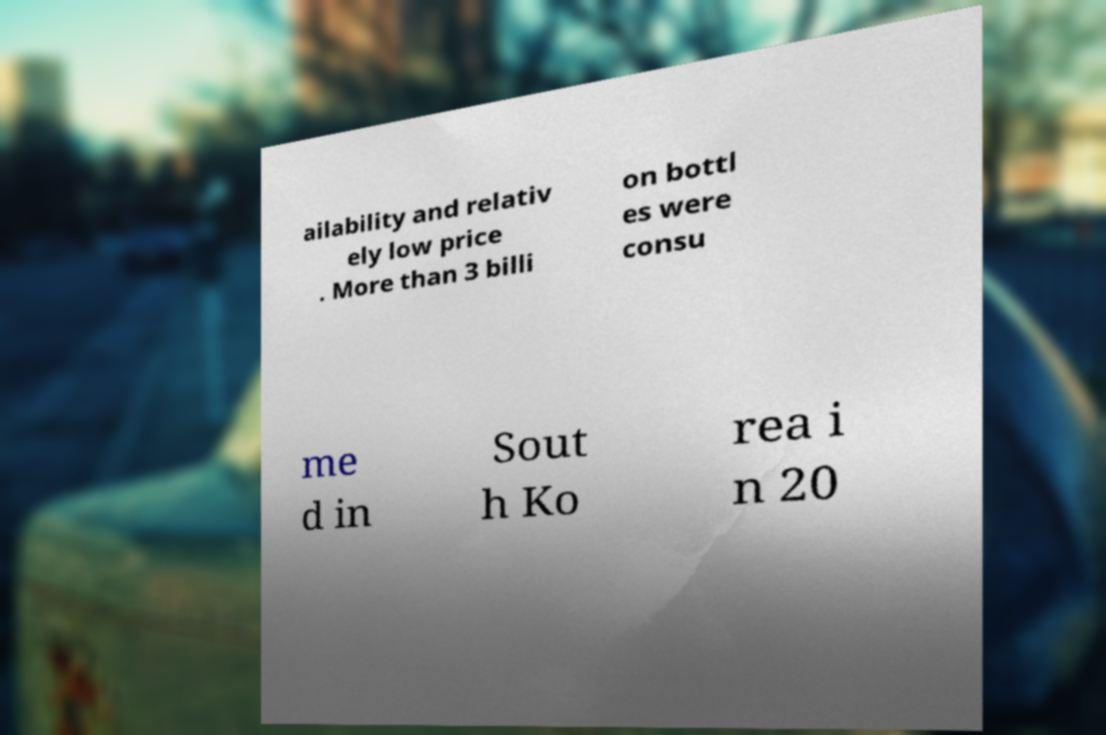I need the written content from this picture converted into text. Can you do that? ailability and relativ ely low price . More than 3 billi on bottl es were consu me d in Sout h Ko rea i n 20 